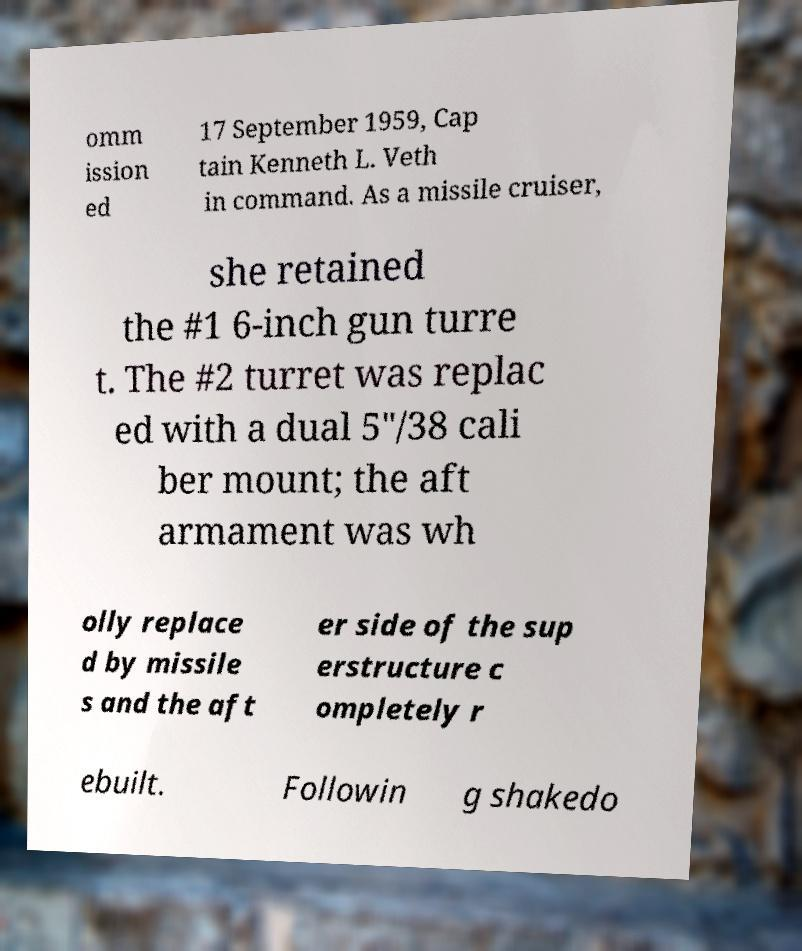For documentation purposes, I need the text within this image transcribed. Could you provide that? omm ission ed 17 September 1959, Cap tain Kenneth L. Veth in command. As a missile cruiser, she retained the #1 6-inch gun turre t. The #2 turret was replac ed with a dual 5"/38 cali ber mount; the aft armament was wh olly replace d by missile s and the aft er side of the sup erstructure c ompletely r ebuilt. Followin g shakedo 